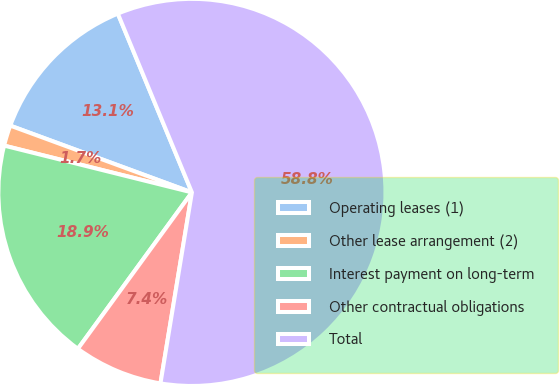<chart> <loc_0><loc_0><loc_500><loc_500><pie_chart><fcel>Operating leases (1)<fcel>Other lease arrangement (2)<fcel>Interest payment on long-term<fcel>Other contractual obligations<fcel>Total<nl><fcel>13.14%<fcel>1.72%<fcel>18.86%<fcel>7.43%<fcel>58.85%<nl></chart> 